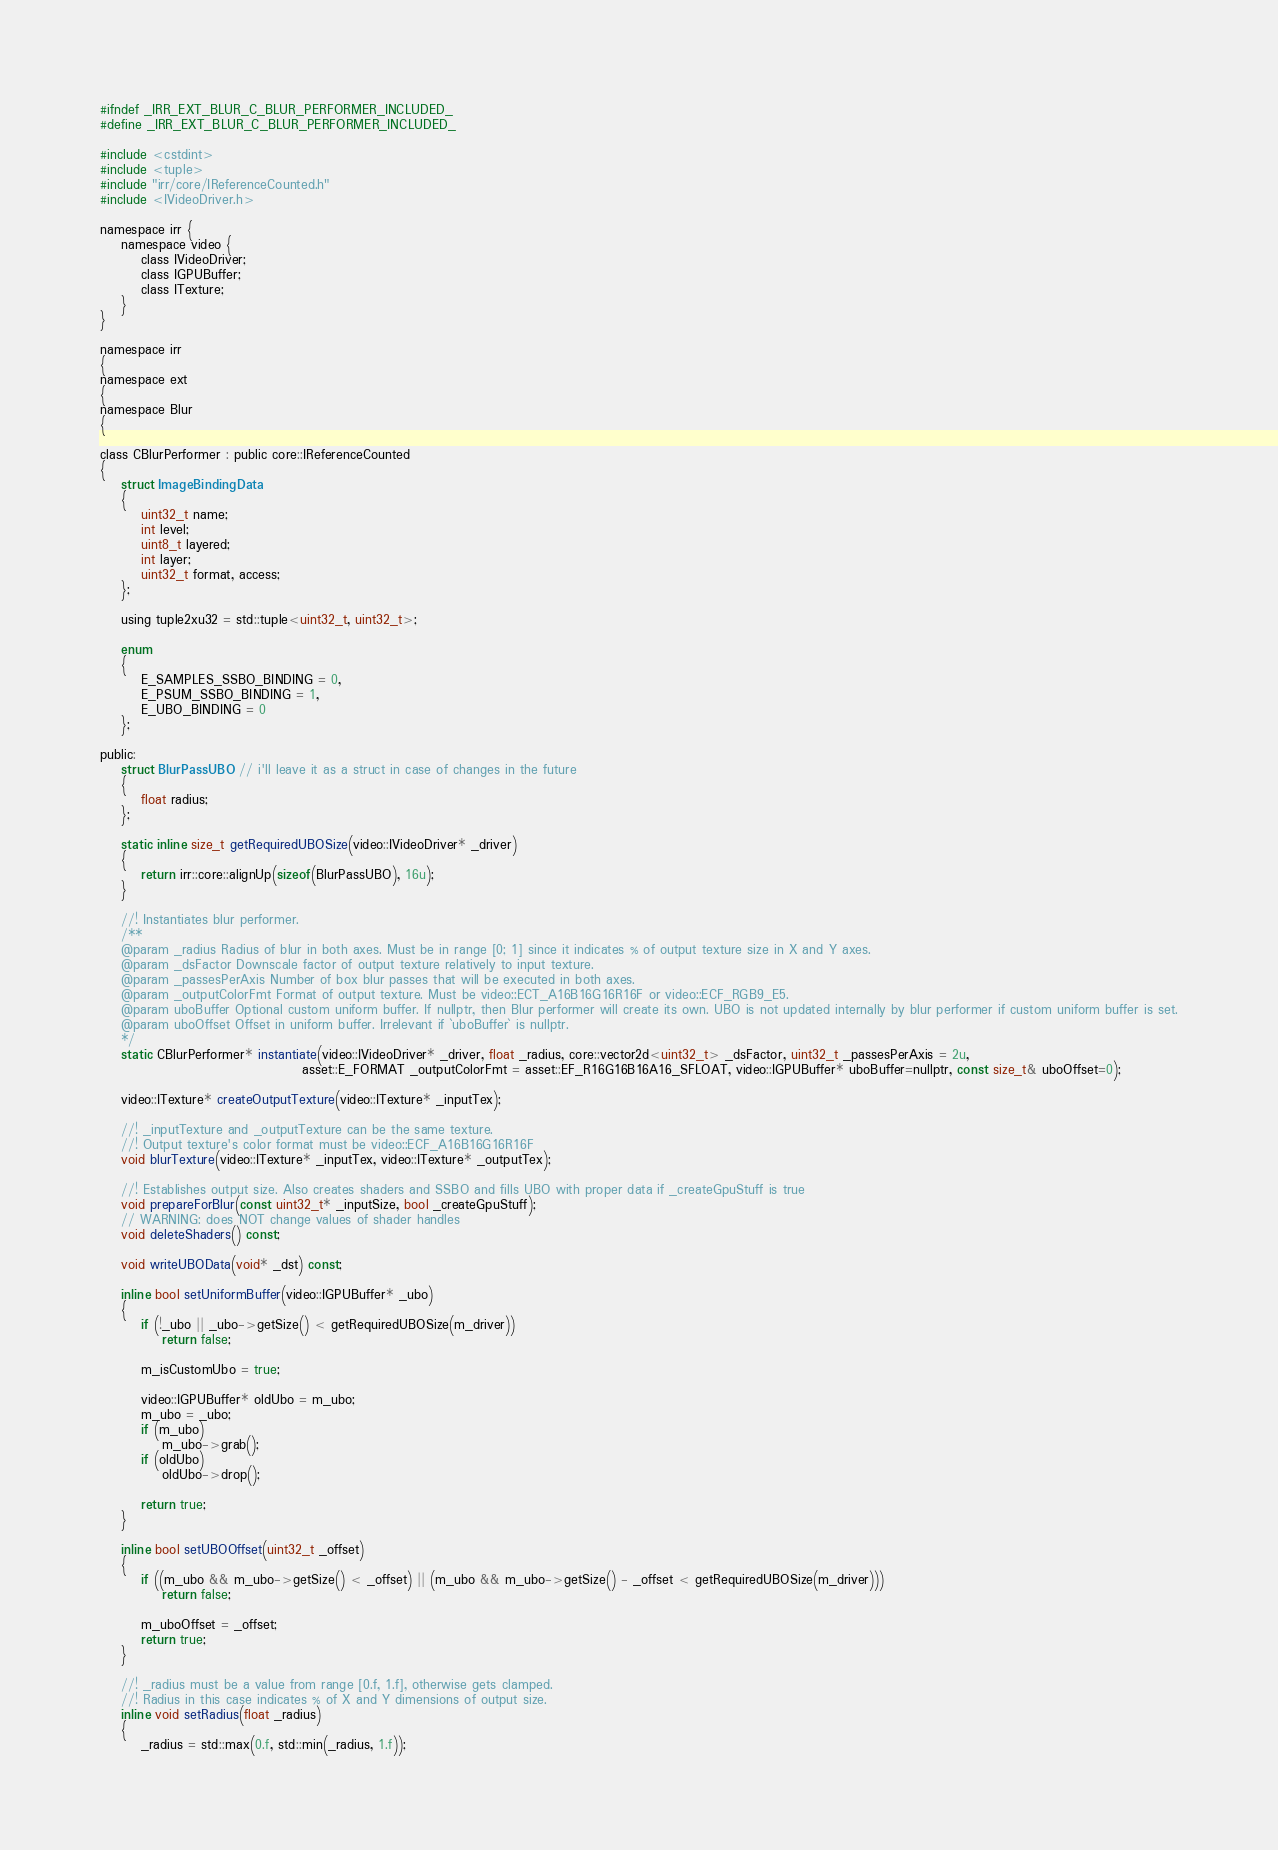Convert code to text. <code><loc_0><loc_0><loc_500><loc_500><_C_>#ifndef _IRR_EXT_BLUR_C_BLUR_PERFORMER_INCLUDED_
#define _IRR_EXT_BLUR_C_BLUR_PERFORMER_INCLUDED_

#include <cstdint>
#include <tuple>
#include "irr/core/IReferenceCounted.h"
#include <IVideoDriver.h>

namespace irr {
    namespace video {
        class IVideoDriver;
        class IGPUBuffer;
        class ITexture;
    }
}

namespace irr
{
namespace ext
{
namespace Blur
{

class CBlurPerformer : public core::IReferenceCounted
{
    struct ImageBindingData
    {
        uint32_t name;
        int level;
        uint8_t layered;
        int layer;
        uint32_t format, access;
    };

    using tuple2xu32 = std::tuple<uint32_t, uint32_t>;

    enum
    {
        E_SAMPLES_SSBO_BINDING = 0,
        E_PSUM_SSBO_BINDING = 1,
        E_UBO_BINDING = 0
    };

public:
    struct BlurPassUBO // i'll leave it as a struct in case of changes in the future
    {
        float radius;
    };

    static inline size_t getRequiredUBOSize(video::IVideoDriver* _driver)
    {
        return irr::core::alignUp(sizeof(BlurPassUBO), 16u);
    }

    //! Instantiates blur performer.
    /**
    @param _radius Radius of blur in both axes. Must be in range [0; 1] since it indicates % of output texture size in X and Y axes.
    @param _dsFactor Downscale factor of output texture relatively to input texture.
    @param _passesPerAxis Number of box blur passes that will be executed in both axes.
    @param _outputColorFmt Format of output texture. Must be video::ECT_A16B16G16R16F or video::ECF_RGB9_E5.
    @param uboBuffer Optional custom uniform buffer. If nullptr, then Blur performer will create its own. UBO is not updated internally by blur performer if custom uniform buffer is set.
    @param uboOffset Offset in uniform buffer. Irrelevant if `uboBuffer` is nullptr.
    */
    static CBlurPerformer* instantiate(video::IVideoDriver* _driver, float _radius, core::vector2d<uint32_t> _dsFactor, uint32_t _passesPerAxis = 2u,
                                       asset::E_FORMAT _outputColorFmt = asset::EF_R16G16B16A16_SFLOAT, video::IGPUBuffer* uboBuffer=nullptr, const size_t& uboOffset=0);

    video::ITexture* createOutputTexture(video::ITexture* _inputTex);

    //! _inputTexture and _outputTexture can be the same texture.
    //! Output texture's color format must be video::ECF_A16B16G16R16F
    void blurTexture(video::ITexture* _inputTex, video::ITexture* _outputTex);

    //! Establishes output size. Also creates shaders and SSBO and fills UBO with proper data if _createGpuStuff is true
    void prepareForBlur(const uint32_t* _inputSize, bool _createGpuStuff);
    // WARNING: does NOT change values of shader handles
    void deleteShaders() const;

    void writeUBOData(void* _dst) const;

    inline bool setUniformBuffer(video::IGPUBuffer* _ubo)
    {
        if (!_ubo || _ubo->getSize() < getRequiredUBOSize(m_driver))
            return false;

        m_isCustomUbo = true;

        video::IGPUBuffer* oldUbo = m_ubo;
        m_ubo = _ubo;
        if (m_ubo)
            m_ubo->grab();
        if (oldUbo)
            oldUbo->drop();

        return true;
    }

    inline bool setUBOOffset(uint32_t _offset)
    {
        if ((m_ubo && m_ubo->getSize() < _offset) || (m_ubo && m_ubo->getSize() - _offset < getRequiredUBOSize(m_driver)))
            return false;

        m_uboOffset = _offset;
        return true;
    }

    //! _radius must be a value from range [0.f, 1.f], otherwise gets clamped.
    //! Radius in this case indicates % of X and Y dimensions of output size.
    inline void setRadius(float _radius)
    {
        _radius = std::max(0.f, std::min(_radius, 1.f));</code> 